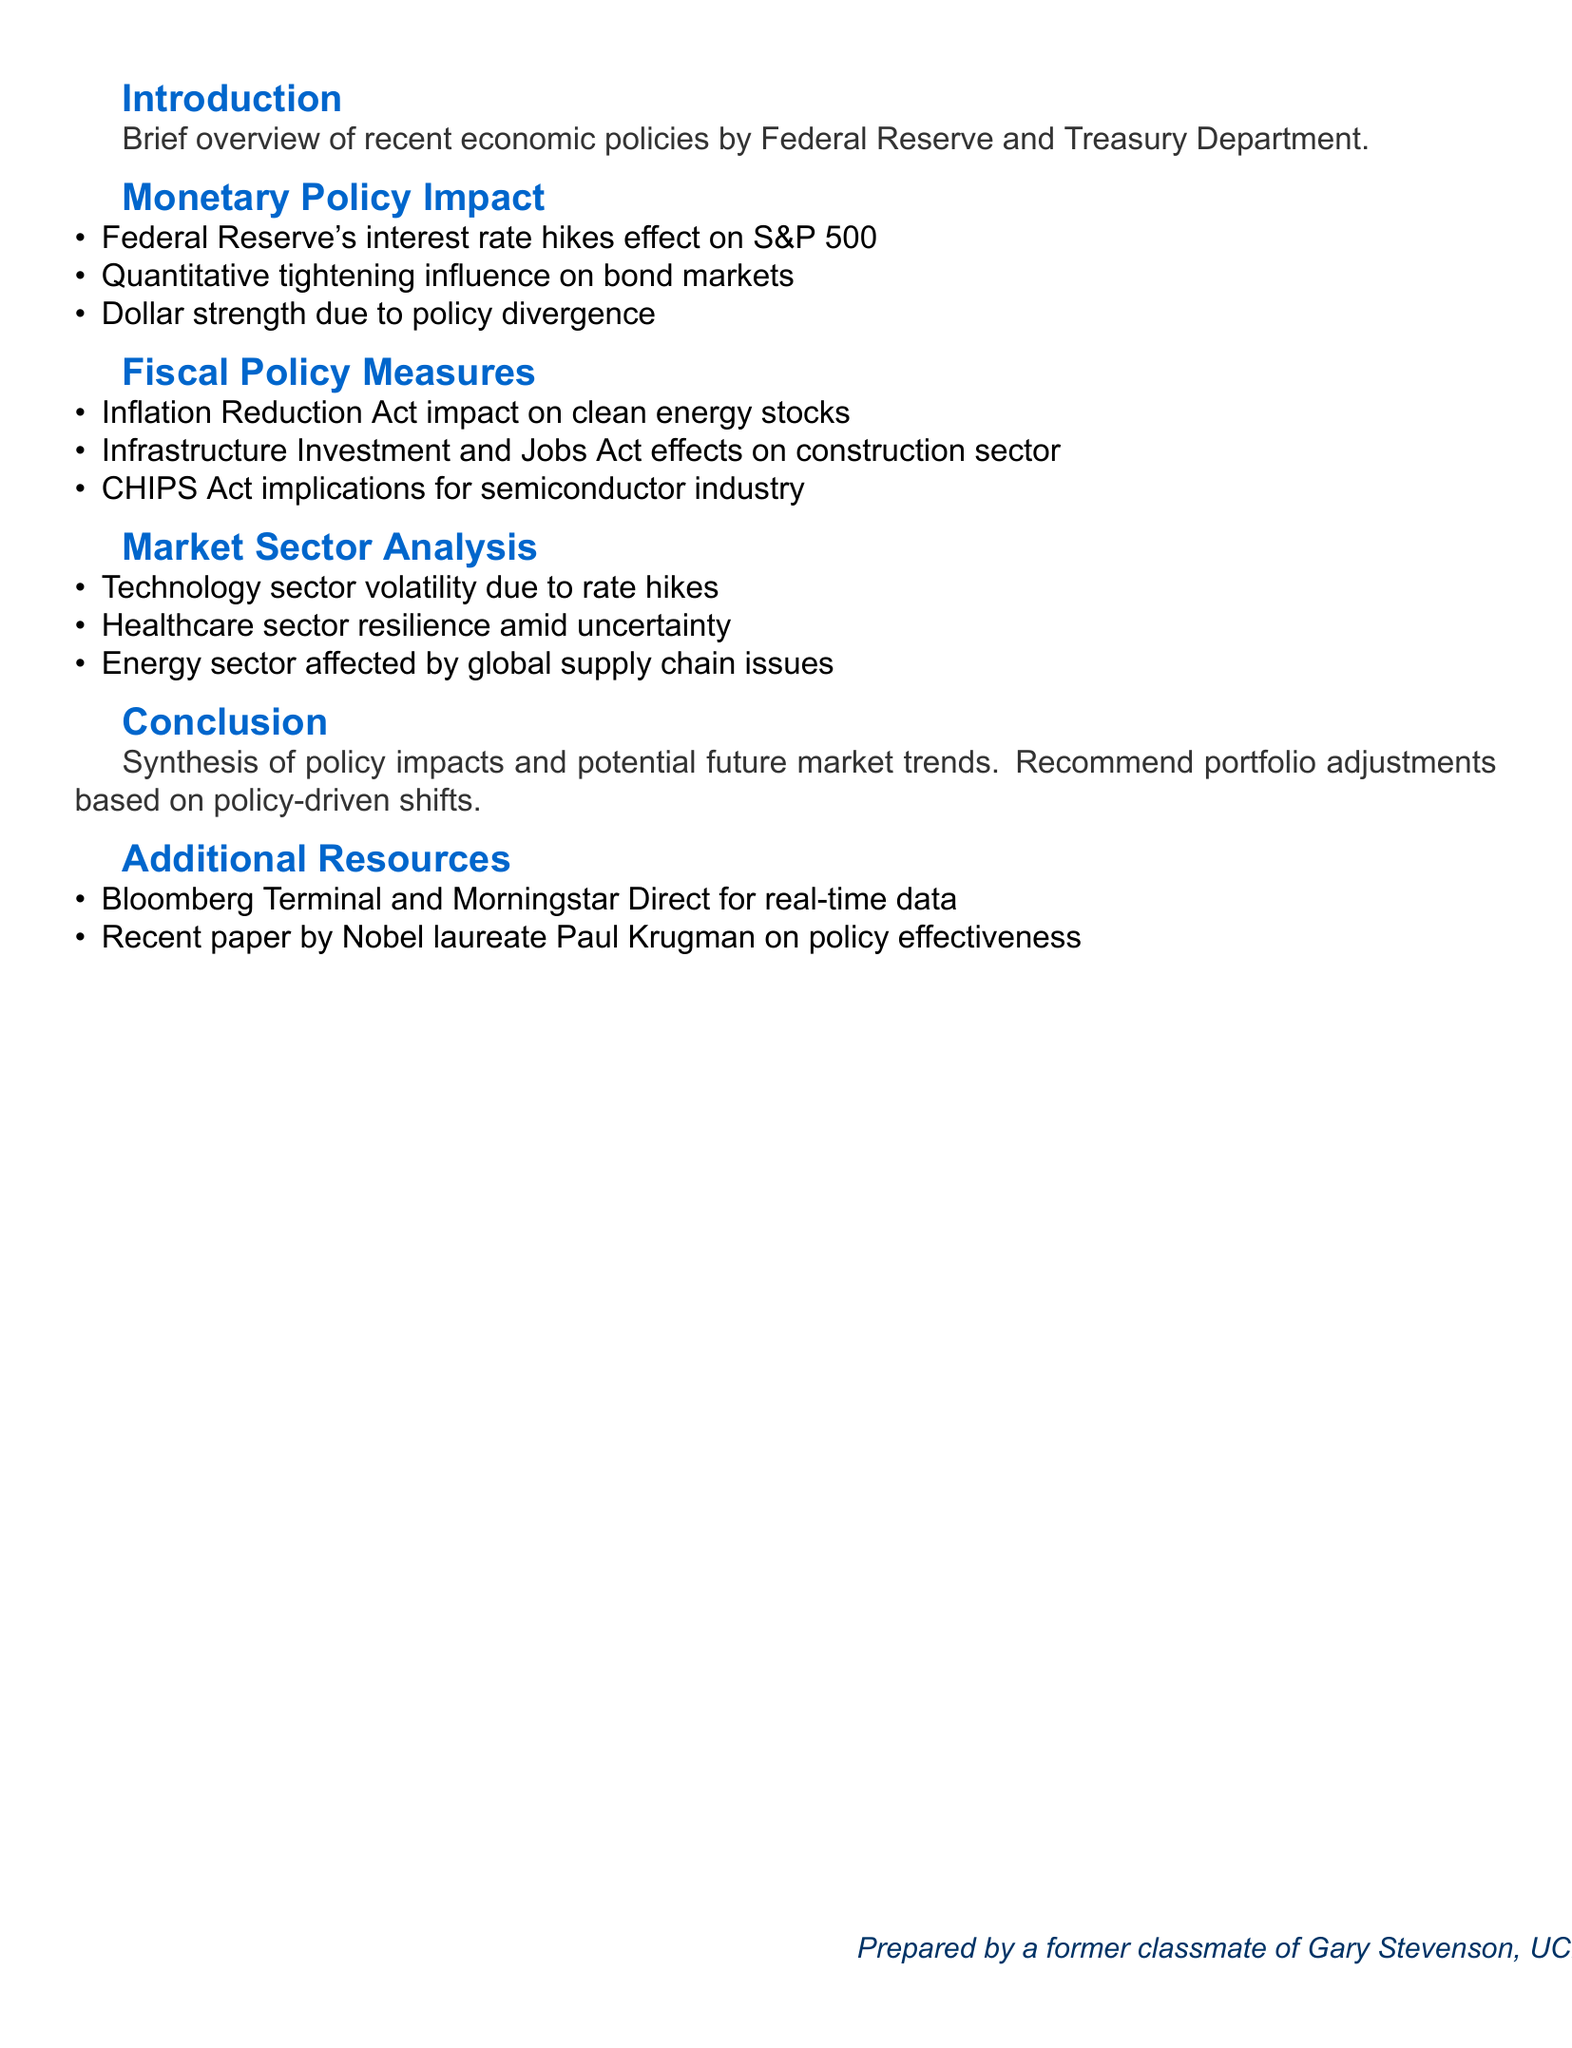what is the title of the presentation? The title of the presentation is prominently stated at the top of the document.
Answer: Economic Policies and Market Performance: A Comprehensive Analysis who is mentioned in the personal note? The personal note includes a reference to a shared experience with a specific individual during college.
Answer: Gary Stevenson what is the main focus of the "Monetary Policy Impact" section? This section discusses several key effects of recent monetary policies, specifically related to interest rates and currency strength.
Answer: Interest rate hikes and their effect on S&P 500 which Act is mentioned as impacting clean energy stocks? The document specifies a particular Act that could influence the performance of clean energy investments.
Answer: Inflation Reduction Act how has the technology sector responded to economic conditions according to the analysis? The analysis indicates the technology sector's reaction to a specific economic stimulus or condition.
Answer: Volatility in response to rate hikes what is included in the "Additional Resources" section? This section provides references that could enhance the understanding of the content presented in the document.
Answer: Bloomberg Terminal and Morningstar Direct for real-time market data what is the final action item recommended in the conclusion? The conclusion includes a specific suggestion related to market strategy based on the discussed economic impacts.
Answer: Recommend portfolio adjustments based on policy-driven market shifts which industry is affected by the CHIPS Act? The document identifies an industry that is suggested to be influenced by a specific piece of legislation.
Answer: Semiconductor industry performance 